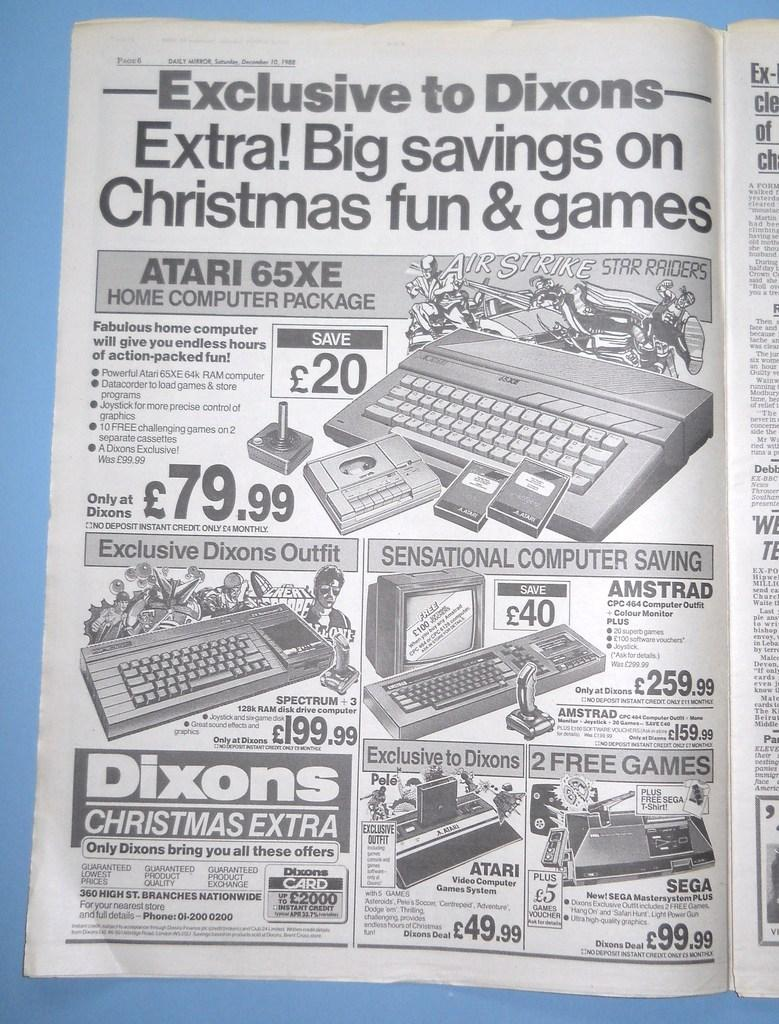What object is visible in the image? There is a book in the image. Where is the book located? The book is placed on a table. Who is talking to the book in the image? There is no person present in the image, so no one is talking to the book. What game is being played with the book in the image? There is no game being played with the book in the image; it is simply placed on a table. 